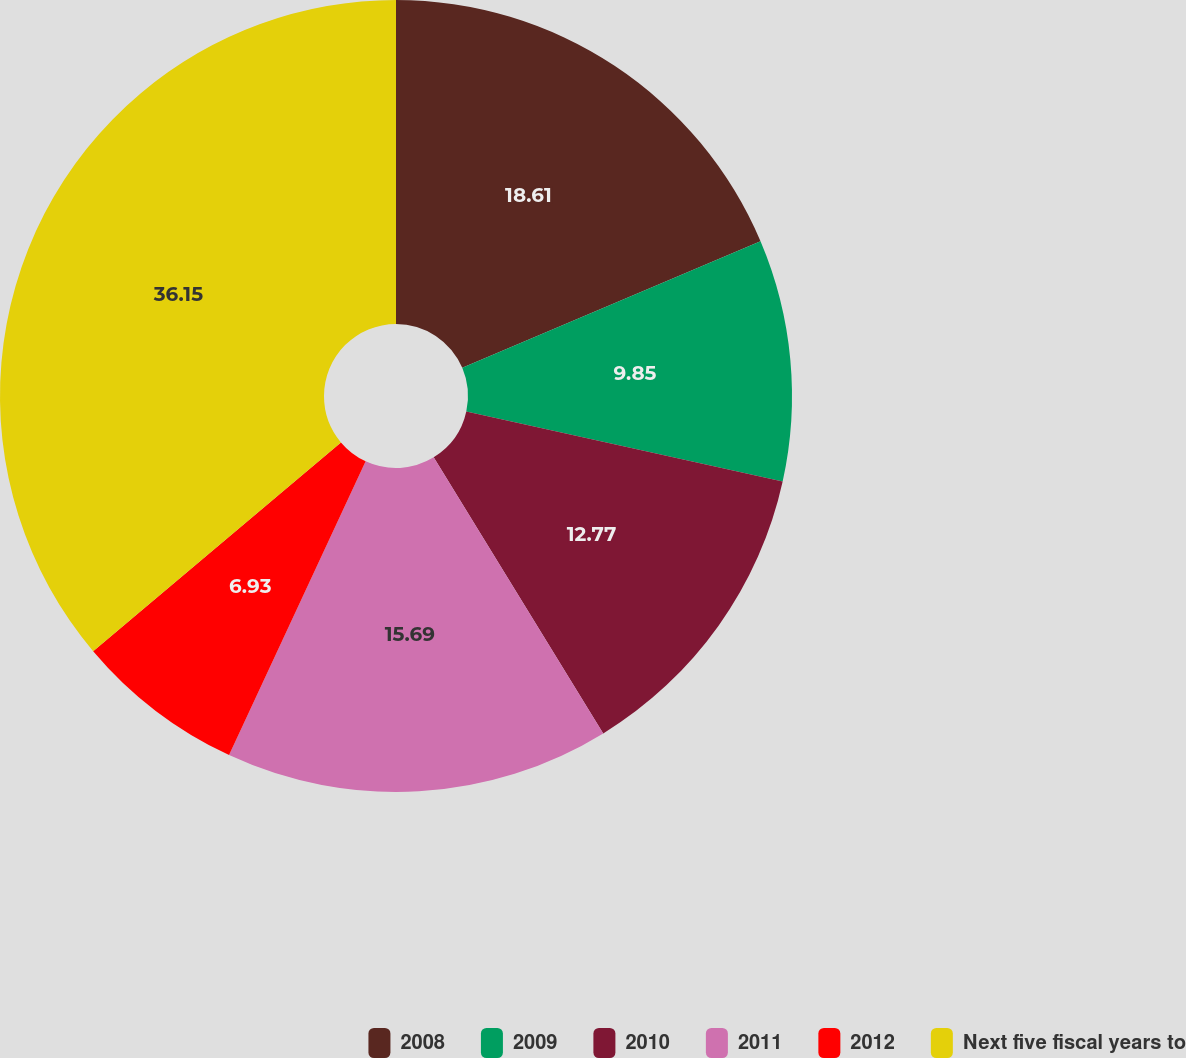Convert chart to OTSL. <chart><loc_0><loc_0><loc_500><loc_500><pie_chart><fcel>2008<fcel>2009<fcel>2010<fcel>2011<fcel>2012<fcel>Next five fiscal years to<nl><fcel>18.61%<fcel>9.85%<fcel>12.77%<fcel>15.69%<fcel>6.93%<fcel>36.14%<nl></chart> 